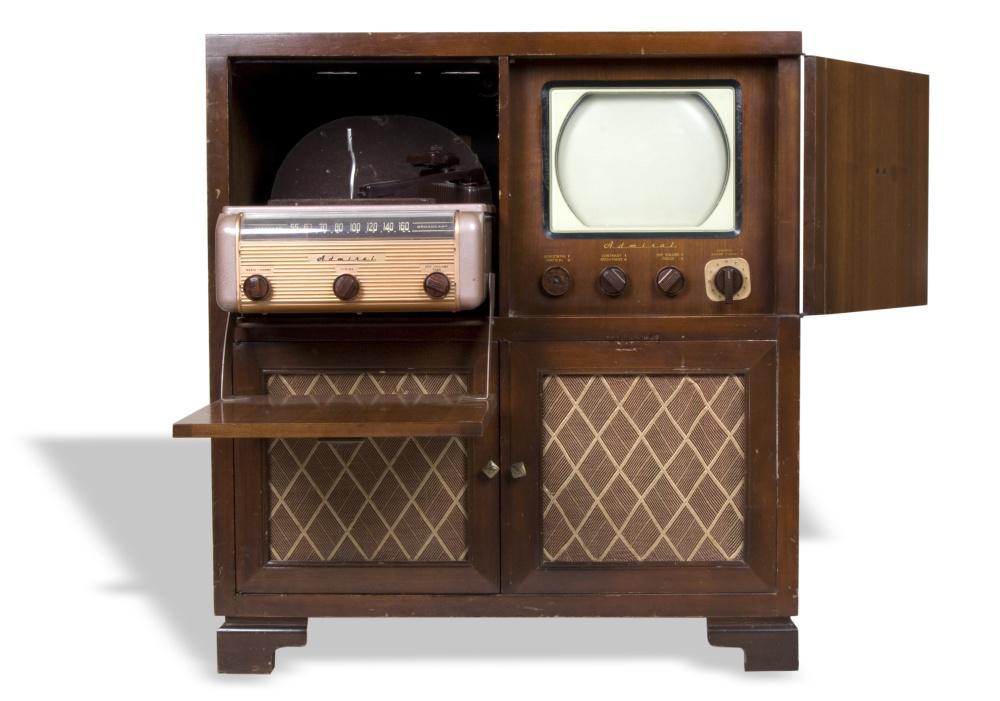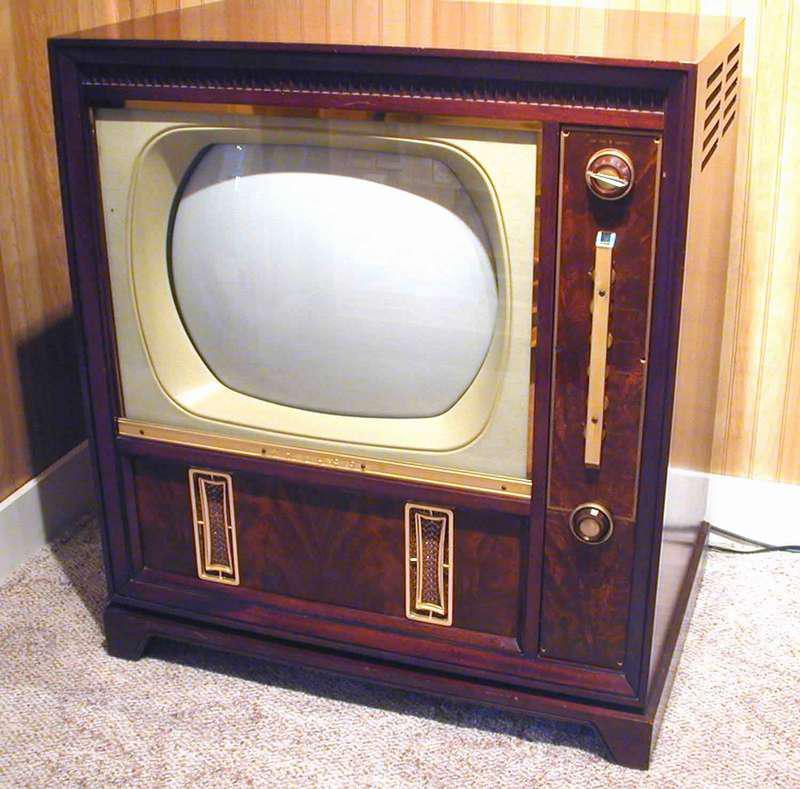The first image is the image on the left, the second image is the image on the right. Considering the images on both sides, is "At least 1 television is part of an open cabinet." valid? Answer yes or no. Yes. The first image is the image on the left, the second image is the image on the right. For the images shown, is this caption "All televisions are large tube screens in wooden cabinets." true? Answer yes or no. Yes. 